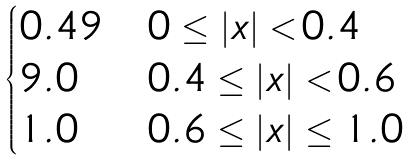Convert formula to latex. <formula><loc_0><loc_0><loc_500><loc_500>\begin{cases} 0 . 4 9 & 0 \leq | x | < 0 . 4 \\ 9 . 0 & 0 . 4 \leq | x | < 0 . 6 \\ 1 . 0 & 0 . 6 \leq | x | \leq 1 . 0 \end{cases}</formula> 